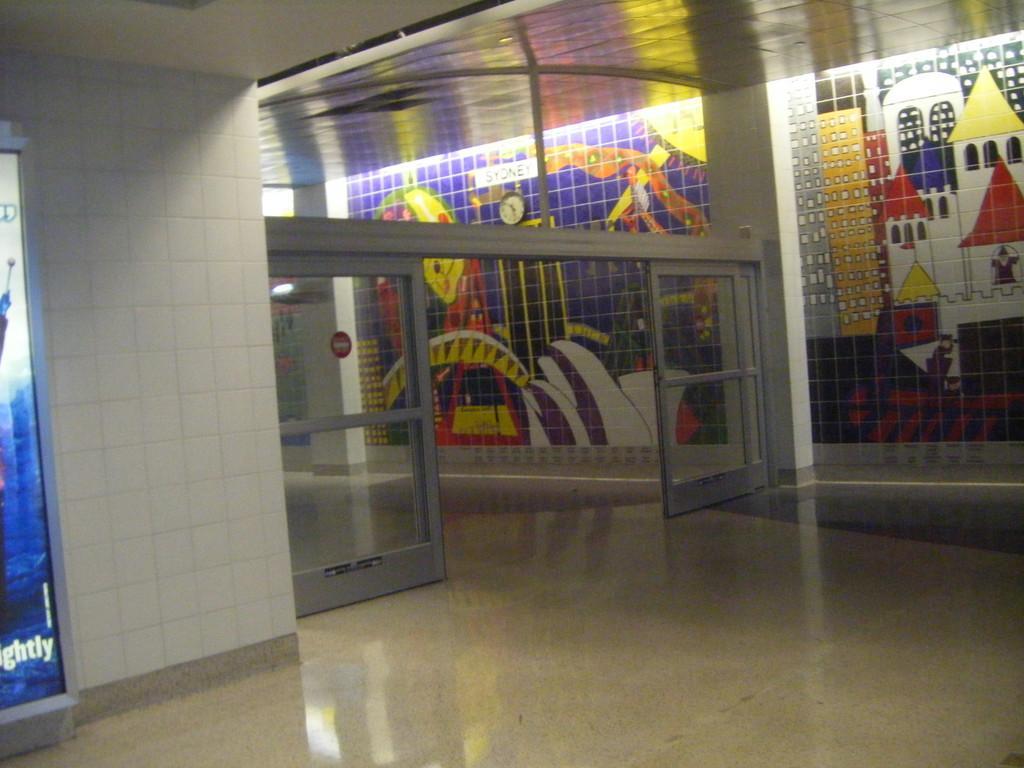Describe this image in one or two sentences. This picture is clicked inside the building. On the left side, we see a board in white and blue color with some text written. Beside that, we see a white wall and beside that, we see the glass doors. In the background, we see a pillar and a wall on which a wall clock is placed. This wall is painted in white, red, yellow and green color. At the top, we see the roof of the building. 